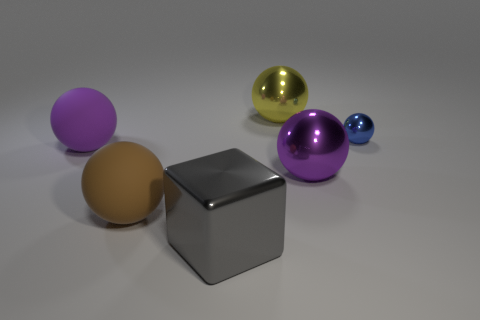Does the big purple thing behind the purple shiny ball have the same shape as the shiny thing behind the tiny blue shiny object?
Provide a short and direct response. Yes. There is a large purple ball that is left of the block; what is its material?
Your response must be concise. Rubber. Does the large yellow object have the same material as the purple sphere that is on the left side of the yellow ball?
Offer a terse response. No. What material is the brown ball that is the same size as the yellow thing?
Keep it short and to the point. Rubber. Are there any small spheres made of the same material as the gray object?
Your answer should be very brief. Yes. Are there fewer big gray blocks that are behind the small blue object than small green matte cylinders?
Give a very brief answer. No. What is the big brown ball that is to the right of the matte object that is behind the brown matte thing made of?
Your answer should be very brief. Rubber. There is a metal object that is behind the big gray object and in front of the tiny blue metallic object; what is its shape?
Your response must be concise. Sphere. How many other things are there of the same color as the small metal object?
Your response must be concise. 0. What number of things are purple shiny balls that are to the left of the small metallic sphere or tiny blue metal objects?
Keep it short and to the point. 2. 